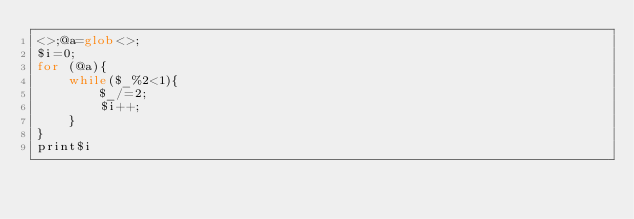<code> <loc_0><loc_0><loc_500><loc_500><_Perl_><>;@a=glob<>;
$i=0;
for (@a){
    while($_%2<1){
        $_/=2;
        $i++;
    }
}
print$i</code> 